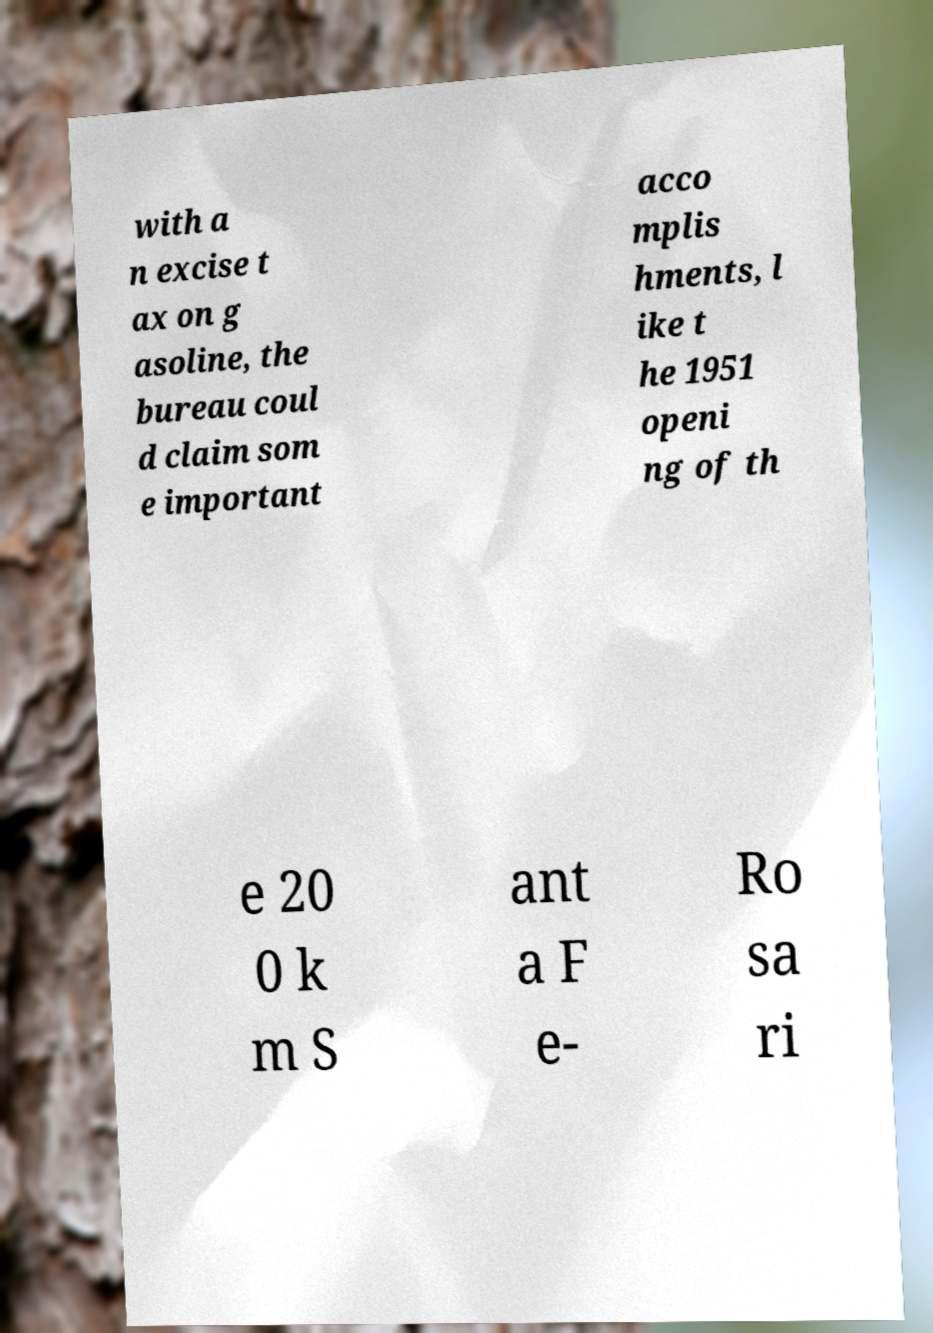What messages or text are displayed in this image? I need them in a readable, typed format. with a n excise t ax on g asoline, the bureau coul d claim som e important acco mplis hments, l ike t he 1951 openi ng of th e 20 0 k m S ant a F e- Ro sa ri 